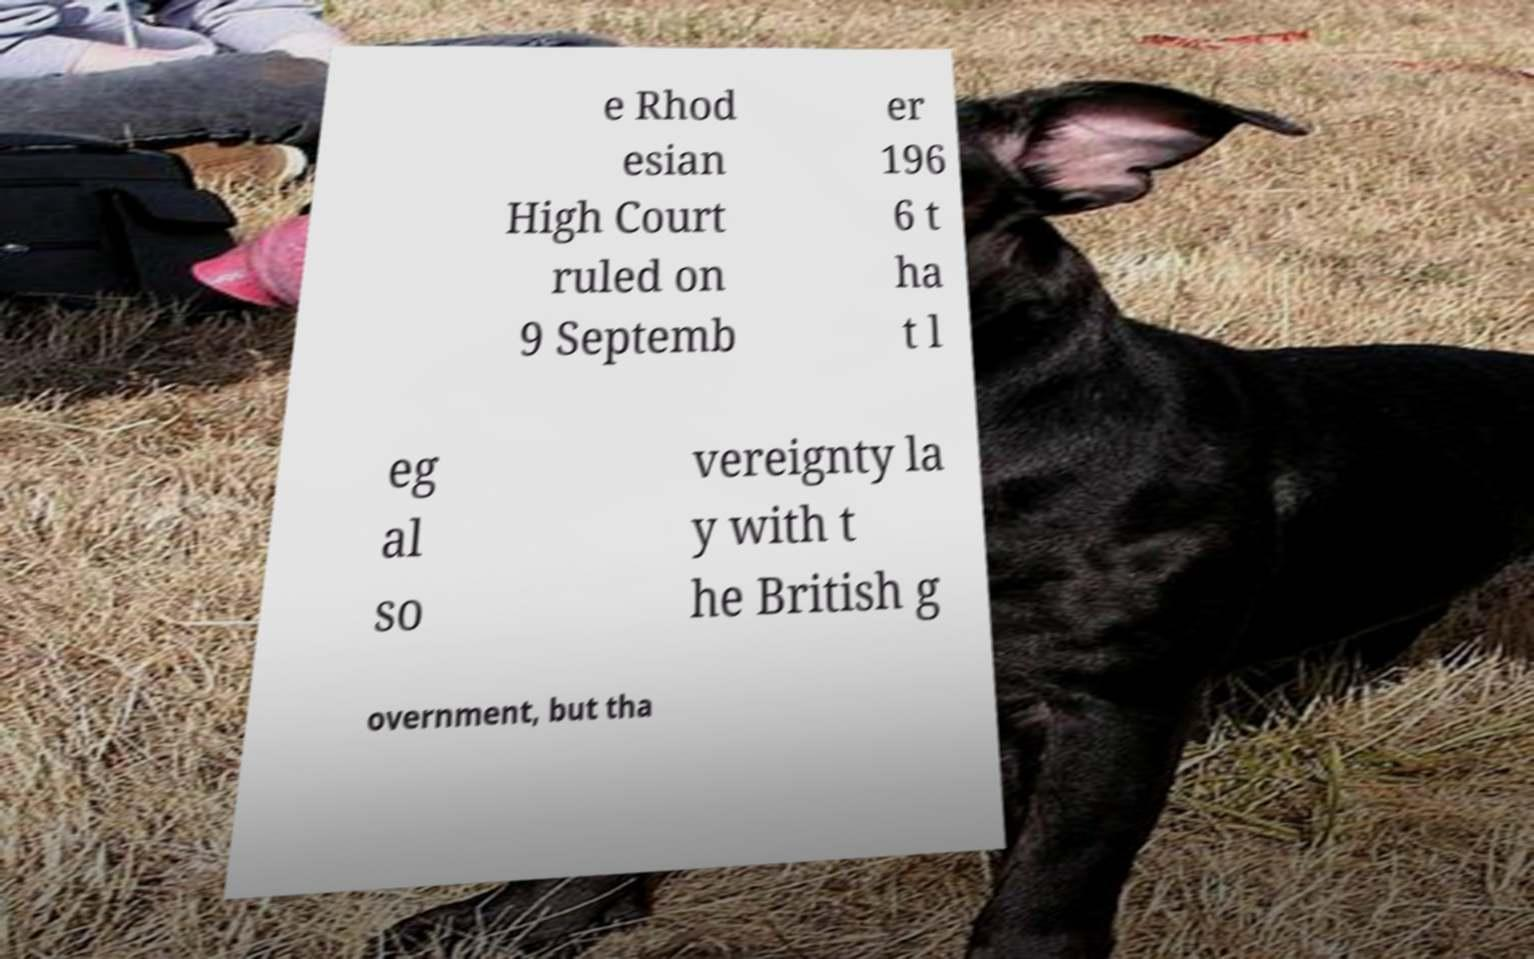Can you accurately transcribe the text from the provided image for me? e Rhod esian High Court ruled on 9 Septemb er 196 6 t ha t l eg al so vereignty la y with t he British g overnment, but tha 